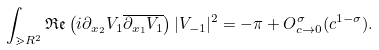Convert formula to latex. <formula><loc_0><loc_0><loc_500><loc_500>\int _ { \mathbb { m } { R } ^ { 2 } } \mathfrak { R } \mathfrak { e } \left ( i \partial _ { x _ { 2 } } V _ { 1 } \overline { \partial _ { x _ { 1 } } V _ { 1 } } \right ) | V _ { - 1 } | ^ { 2 } = - \pi + O ^ { \sigma } _ { c \rightarrow 0 } ( c ^ { 1 - \sigma } ) .</formula> 